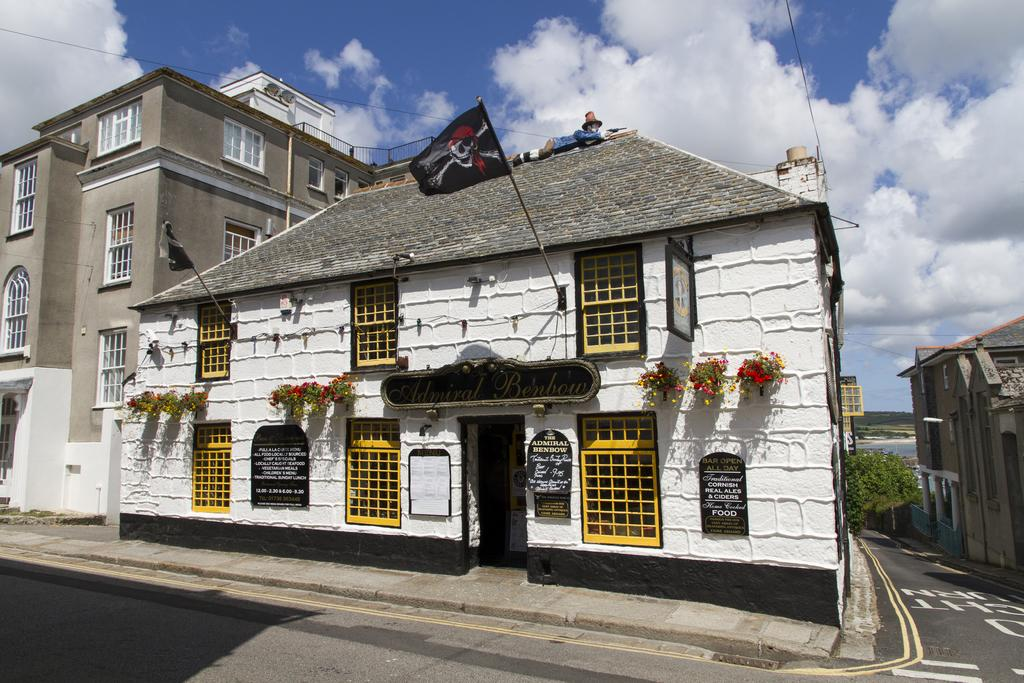What type of path can be seen in the image? There is a footpath in the image. What else is present alongside the footpath? There is a road in the image. Can you describe the person in the image? There is a person in the image, but their appearance or actions are not specified. What type of vegetation is present in the image? There are flowers and trees in the image. What type of structures are visible in the image? There are buildings with windows in the image. What else can be seen in the image? There are name boards and some objects in the image. What is visible in the background of the image? The sky is visible in the background of the image, with clouds present. How many stars can be seen in the image? There are no stars visible in the image. What type of lead is the person holding in the image? There is no lead present in the image, and the person's actions are not specified. 